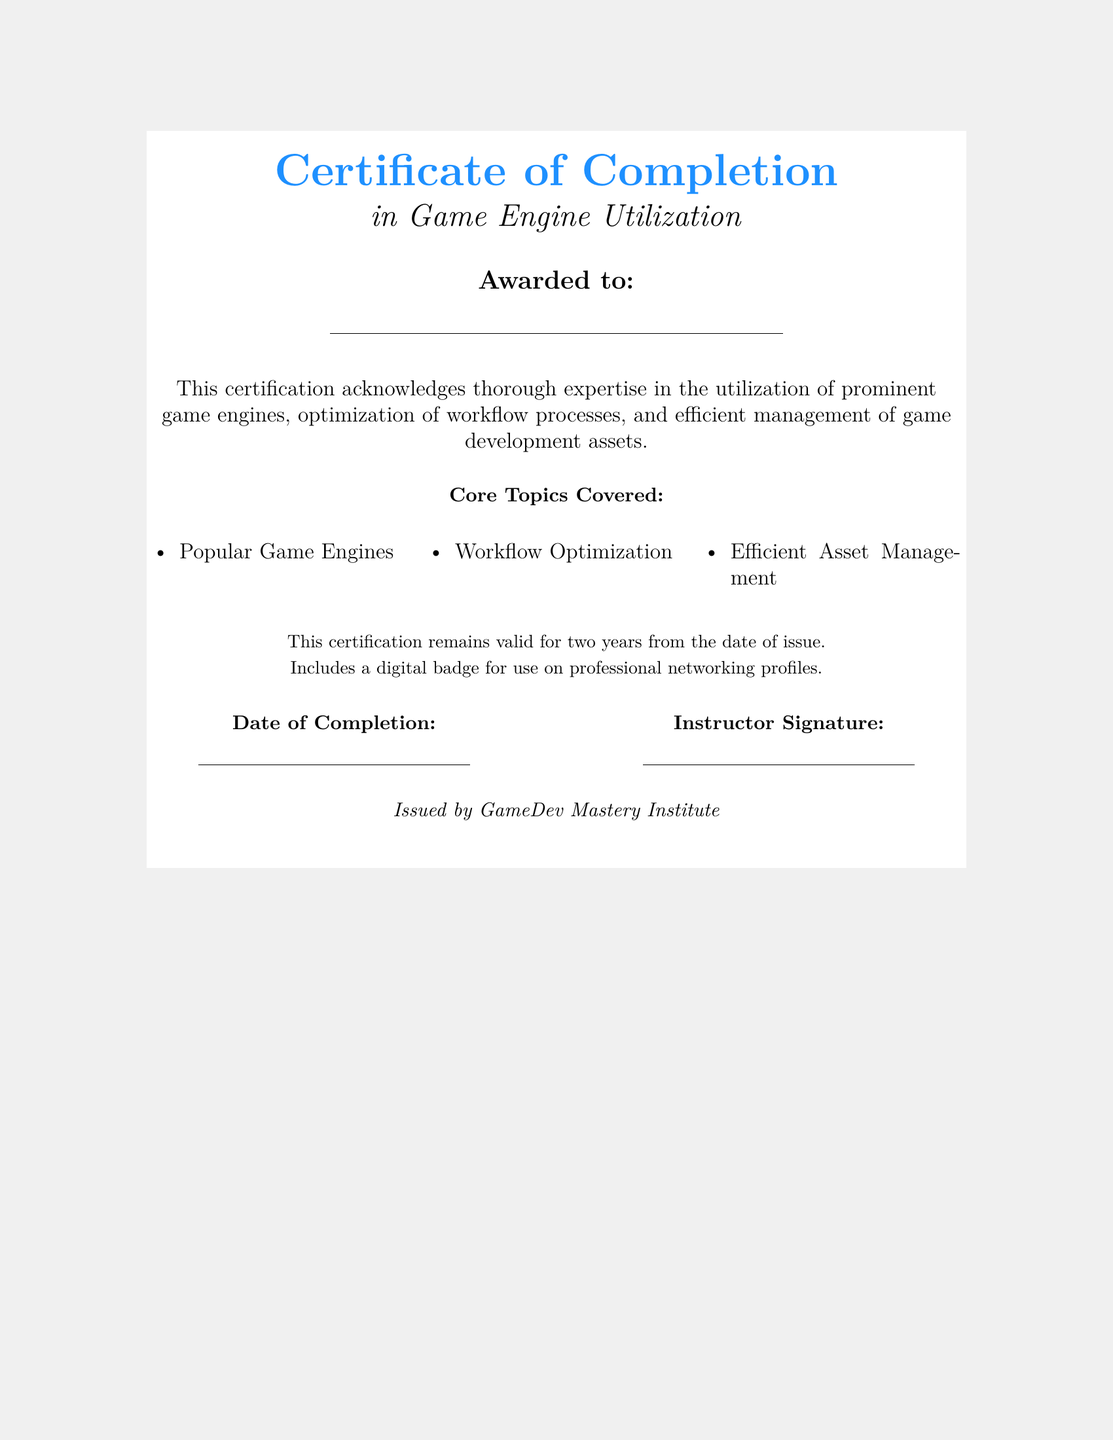What is the title of the certificate? The title is prominently displayed at the top of the document.
Answer: Certificate of Completion Who is awarded this certificate? The space for the recipient's name is provided below the award title.
Answer: Awarded to: What are the core topics covered by the certification? The core topics are listed under "Core Topics Covered."
Answer: Popular Game Engines, Workflow Optimization, Efficient Asset Management What is the validity period of this certification? The document states the duration of validity at the end.
Answer: Two years What is included with the certification? The document mentions a specific digital item related to professional use.
Answer: Digital badge What institution issued the certificate? The issuing body is stated at the bottom of the document.
Answer: GameDev Mastery Institute What are the two fields for recording additional information on the certificate? The fields in the document indicate spaces for specific details.
Answer: Date of Completion, Instructor Signature What color is used for the title text? The document defines a specific color for the title, visible at the top.
Answer: Gameblue What is the style of the certificate background? The background color is mentioned in the document properties.
Answer: Gamegray 